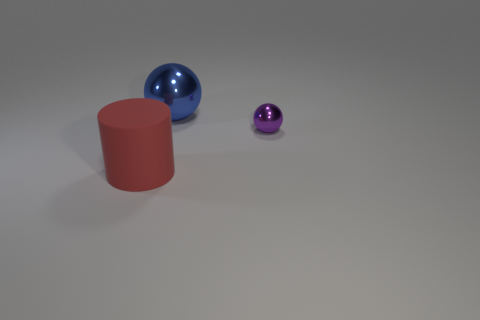Add 3 large blue metallic blocks. How many objects exist? 6 Subtract all cylinders. How many objects are left? 2 Subtract 0 yellow blocks. How many objects are left? 3 Subtract all large blue shiny spheres. Subtract all blue spheres. How many objects are left? 1 Add 1 small spheres. How many small spheres are left? 2 Add 1 purple matte cylinders. How many purple matte cylinders exist? 1 